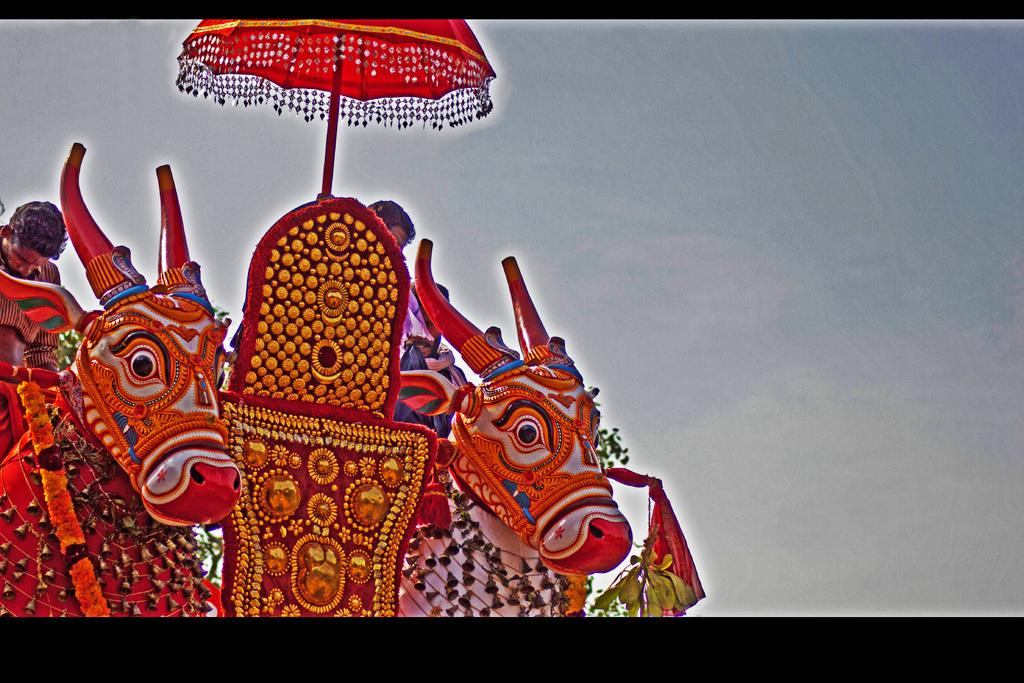What animals can be seen in the image? There are cows in the image. Are there any people present in the image? Yes, there are people in the image. What object can be seen providing shade in the image? There is an umbrella in the image. What type of decorative objects are present in the image? Decorative objects are present in the image, but their specific nature is not mentioned in the facts. What type of vegetation is visible in the image? Leaves are visible in the image. What can be seen in the background of the image? The sky is visible in the background of the image. What type of teeth can be seen on the rose in the image? There is no rose present in the image, and therefore no teeth can be observed on it. 